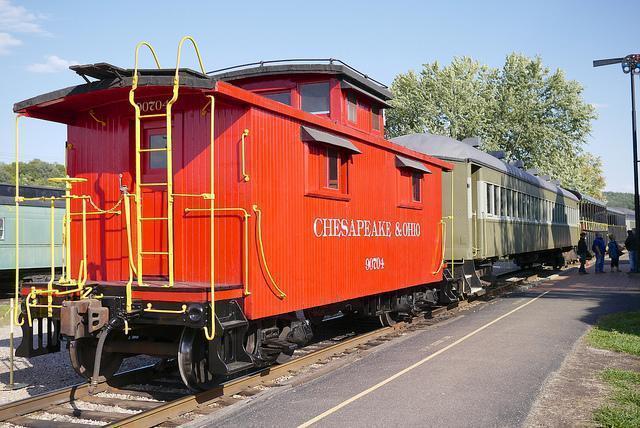The Chesapeake and Ohio Railway was a Class I railroad formed when?
Answer the question by selecting the correct answer among the 4 following choices.
Options: 1888, 1958, 1869, 1858. 1869. 